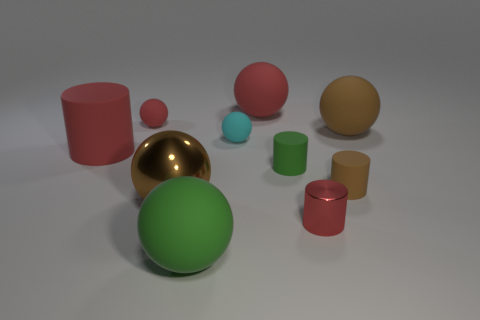Subtract all big red cylinders. How many cylinders are left? 3 Subtract all purple cylinders. How many brown spheres are left? 2 Subtract all red balls. How many balls are left? 4 Subtract 0 cyan cylinders. How many objects are left? 10 Subtract all cylinders. How many objects are left? 6 Subtract 4 cylinders. How many cylinders are left? 0 Subtract all blue cylinders. Subtract all blue spheres. How many cylinders are left? 4 Subtract all brown cylinders. Subtract all small red metal cubes. How many objects are left? 9 Add 8 cyan rubber objects. How many cyan rubber objects are left? 9 Add 7 big green shiny cubes. How many big green shiny cubes exist? 7 